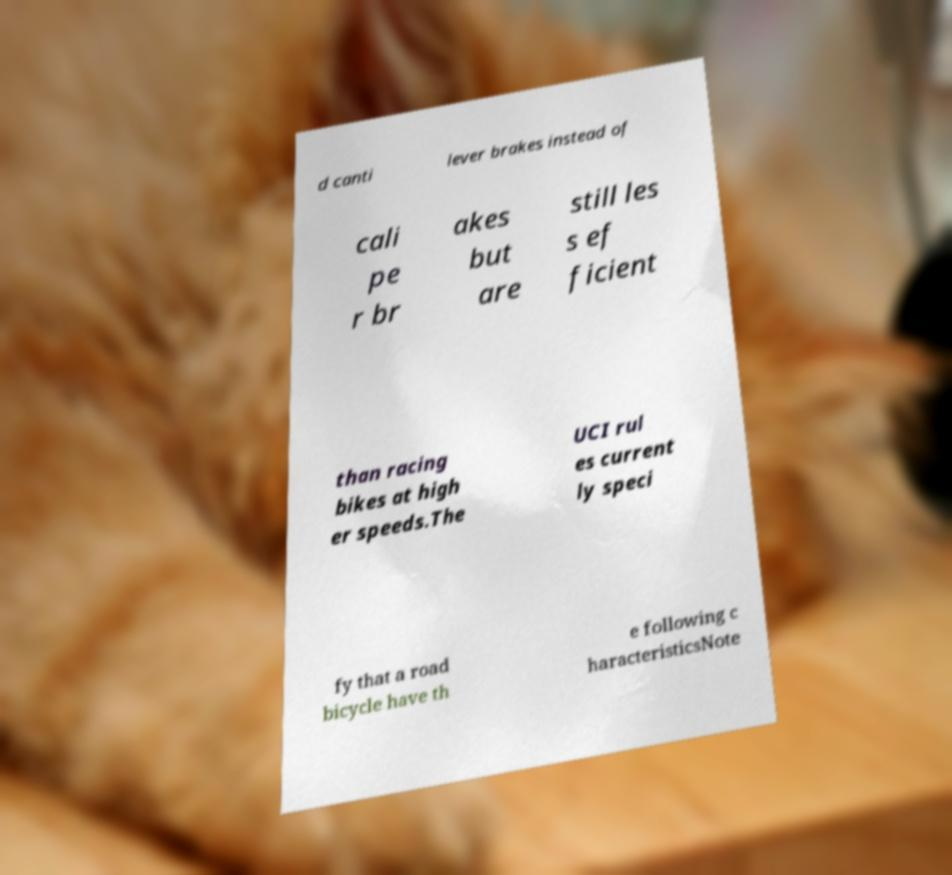I need the written content from this picture converted into text. Can you do that? d canti lever brakes instead of cali pe r br akes but are still les s ef ficient than racing bikes at high er speeds.The UCI rul es current ly speci fy that a road bicycle have th e following c haracteristicsNote 